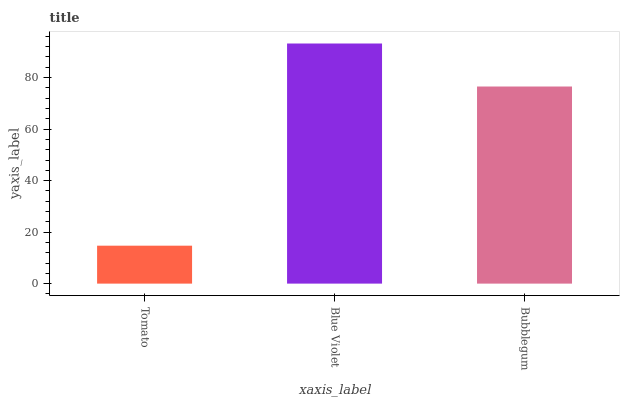Is Tomato the minimum?
Answer yes or no. Yes. Is Blue Violet the maximum?
Answer yes or no. Yes. Is Bubblegum the minimum?
Answer yes or no. No. Is Bubblegum the maximum?
Answer yes or no. No. Is Blue Violet greater than Bubblegum?
Answer yes or no. Yes. Is Bubblegum less than Blue Violet?
Answer yes or no. Yes. Is Bubblegum greater than Blue Violet?
Answer yes or no. No. Is Blue Violet less than Bubblegum?
Answer yes or no. No. Is Bubblegum the high median?
Answer yes or no. Yes. Is Bubblegum the low median?
Answer yes or no. Yes. Is Tomato the high median?
Answer yes or no. No. Is Tomato the low median?
Answer yes or no. No. 